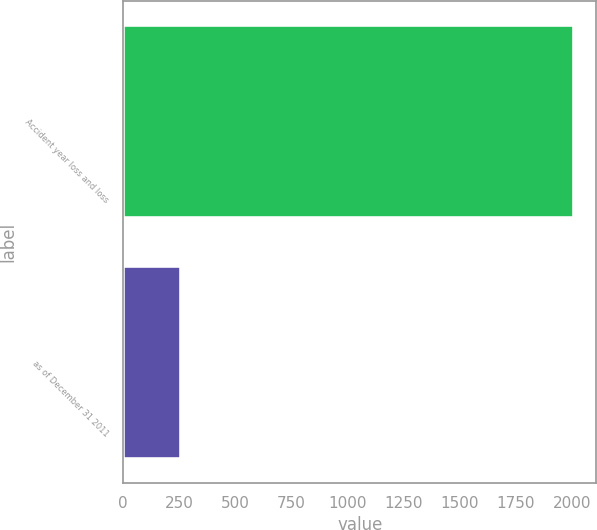Convert chart. <chart><loc_0><loc_0><loc_500><loc_500><bar_chart><fcel>Accident year loss and loss<fcel>as of December 31 2011<nl><fcel>2010<fcel>259<nl></chart> 